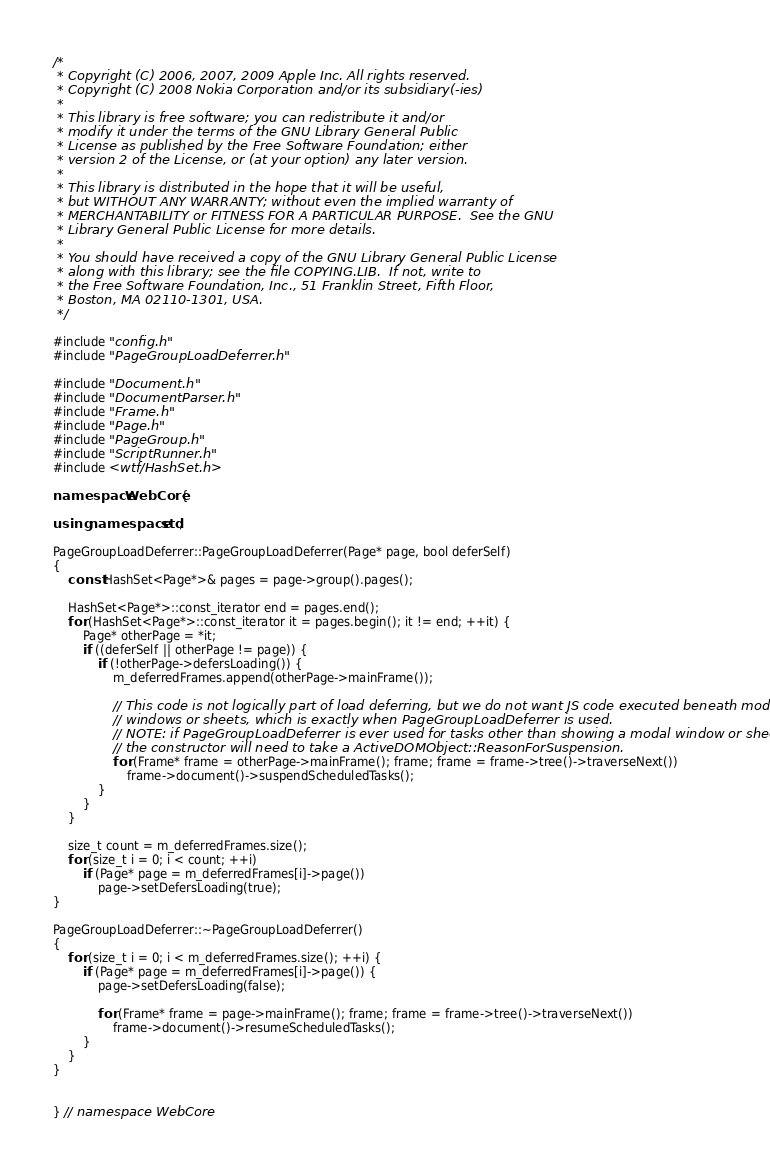<code> <loc_0><loc_0><loc_500><loc_500><_C++_>/*
 * Copyright (C) 2006, 2007, 2009 Apple Inc. All rights reserved.
 * Copyright (C) 2008 Nokia Corporation and/or its subsidiary(-ies)
 *
 * This library is free software; you can redistribute it and/or
 * modify it under the terms of the GNU Library General Public
 * License as published by the Free Software Foundation; either
 * version 2 of the License, or (at your option) any later version.
 *
 * This library is distributed in the hope that it will be useful,
 * but WITHOUT ANY WARRANTY; without even the implied warranty of
 * MERCHANTABILITY or FITNESS FOR A PARTICULAR PURPOSE.  See the GNU
 * Library General Public License for more details.
 *
 * You should have received a copy of the GNU Library General Public License
 * along with this library; see the file COPYING.LIB.  If not, write to
 * the Free Software Foundation, Inc., 51 Franklin Street, Fifth Floor,
 * Boston, MA 02110-1301, USA.
 */

#include "config.h"
#include "PageGroupLoadDeferrer.h"

#include "Document.h"
#include "DocumentParser.h"
#include "Frame.h"
#include "Page.h"
#include "PageGroup.h"
#include "ScriptRunner.h"
#include <wtf/HashSet.h>

namespace WebCore {

using namespace std;

PageGroupLoadDeferrer::PageGroupLoadDeferrer(Page* page, bool deferSelf)
{
    const HashSet<Page*>& pages = page->group().pages();

    HashSet<Page*>::const_iterator end = pages.end();
    for (HashSet<Page*>::const_iterator it = pages.begin(); it != end; ++it) {
        Page* otherPage = *it;
        if ((deferSelf || otherPage != page)) {
            if (!otherPage->defersLoading()) {
                m_deferredFrames.append(otherPage->mainFrame());

                // This code is not logically part of load deferring, but we do not want JS code executed beneath modal
                // windows or sheets, which is exactly when PageGroupLoadDeferrer is used.
                // NOTE: if PageGroupLoadDeferrer is ever used for tasks other than showing a modal window or sheet,
                // the constructor will need to take a ActiveDOMObject::ReasonForSuspension.
                for (Frame* frame = otherPage->mainFrame(); frame; frame = frame->tree()->traverseNext())
                    frame->document()->suspendScheduledTasks();
            }
        }
    }

    size_t count = m_deferredFrames.size();
    for (size_t i = 0; i < count; ++i)
        if (Page* page = m_deferredFrames[i]->page())
            page->setDefersLoading(true);
}

PageGroupLoadDeferrer::~PageGroupLoadDeferrer()
{
    for (size_t i = 0; i < m_deferredFrames.size(); ++i) {
        if (Page* page = m_deferredFrames[i]->page()) {
            page->setDefersLoading(false);

            for (Frame* frame = page->mainFrame(); frame; frame = frame->tree()->traverseNext())
                frame->document()->resumeScheduledTasks();
        }
    }
}


} // namespace WebCore
</code> 